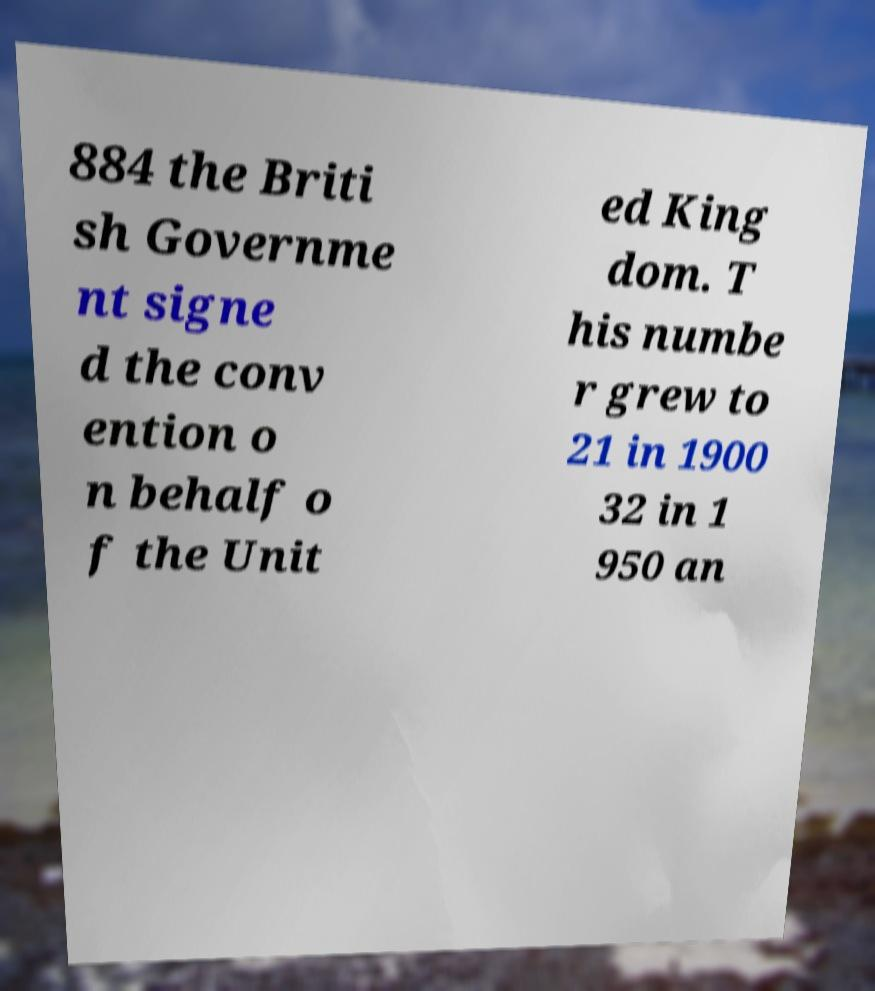Can you read and provide the text displayed in the image?This photo seems to have some interesting text. Can you extract and type it out for me? 884 the Briti sh Governme nt signe d the conv ention o n behalf o f the Unit ed King dom. T his numbe r grew to 21 in 1900 32 in 1 950 an 